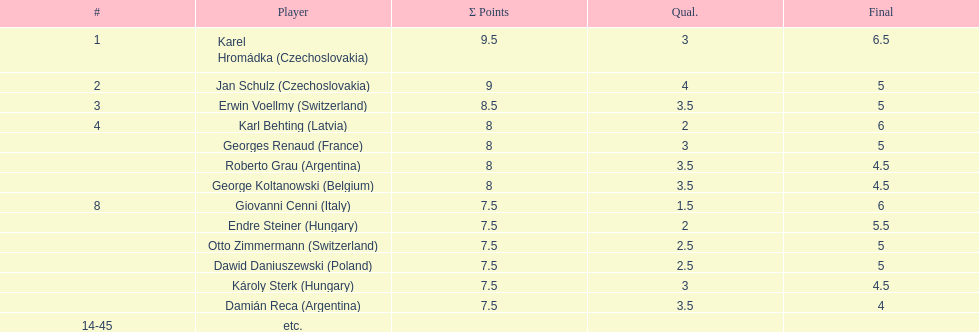Did the pair of competitors from hungary achieve more or fewer combined points than the pair from argentina? Less. 